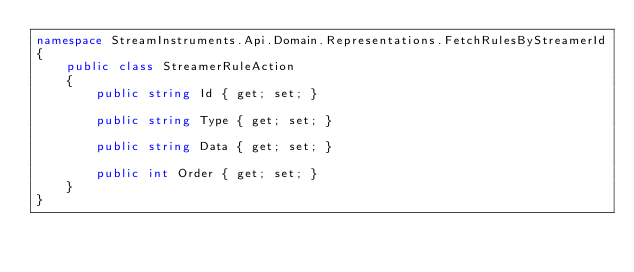Convert code to text. <code><loc_0><loc_0><loc_500><loc_500><_C#_>namespace StreamInstruments.Api.Domain.Representations.FetchRulesByStreamerId
{
    public class StreamerRuleAction
    {
        public string Id { get; set; }

        public string Type { get; set; }

        public string Data { get; set; }

        public int Order { get; set; }
    }
}</code> 